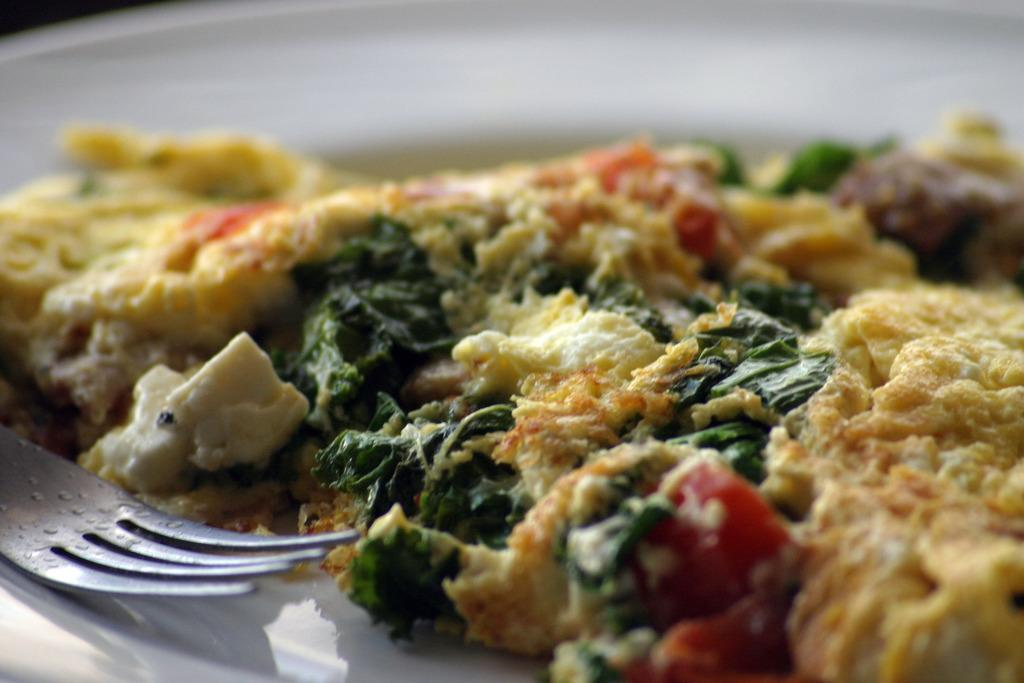What is present on the plate in the image? There is food on a plate in the image. What type of utensil is on the left side of the plate? There is a fork on the left side of the plate. What color is the plate in the image? The plate is white. How does the fish contribute to the comfort of the person eating the food in the image? There is no fish present in the image, so it cannot contribute to the comfort of the person eating the food. 